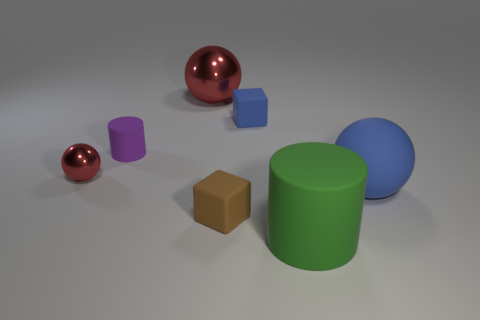Subtract all large blue balls. How many balls are left? 2 Add 3 small red things. How many objects exist? 10 Subtract all blue cubes. How many cubes are left? 1 Subtract all cylinders. How many objects are left? 5 Subtract 2 cylinders. How many cylinders are left? 0 Subtract all purple blocks. How many red balls are left? 2 Subtract all big blue things. Subtract all big cyan metal objects. How many objects are left? 6 Add 5 large objects. How many large objects are left? 8 Add 3 big green matte cylinders. How many big green matte cylinders exist? 4 Subtract 0 purple cubes. How many objects are left? 7 